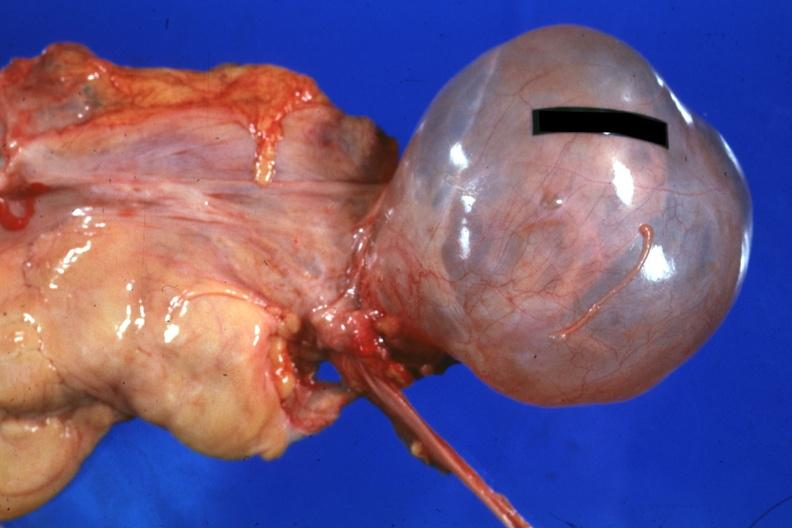what is present?
Answer the question using a single word or phrase. Female reproductive 